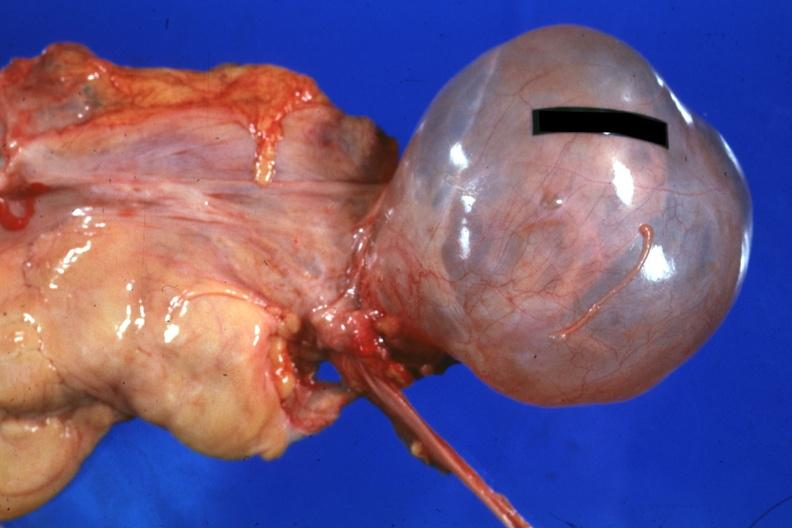what is present?
Answer the question using a single word or phrase. Female reproductive 